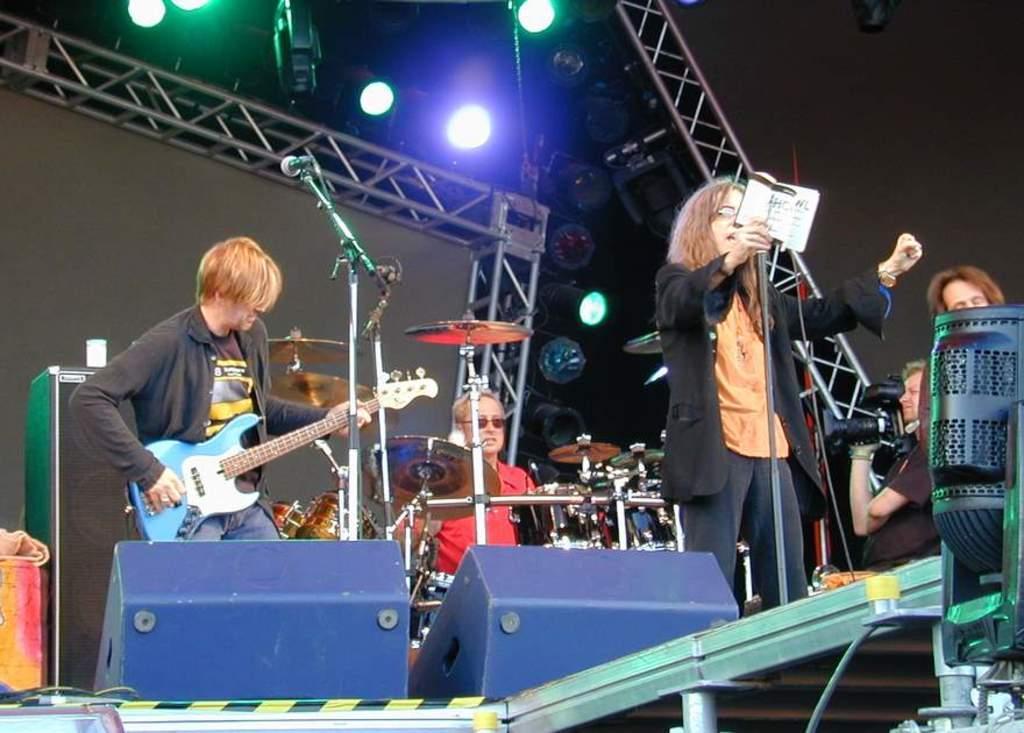In one or two sentences, can you explain what this image depicts? As we can see in the image there are lights, few people over here. The man on the left side is holding guitar and in front of him there is a mic. The man who is sitting here is playing musical drums and the women over is holding mic and singing a song and the man on the right side is sitting and holding camera. 